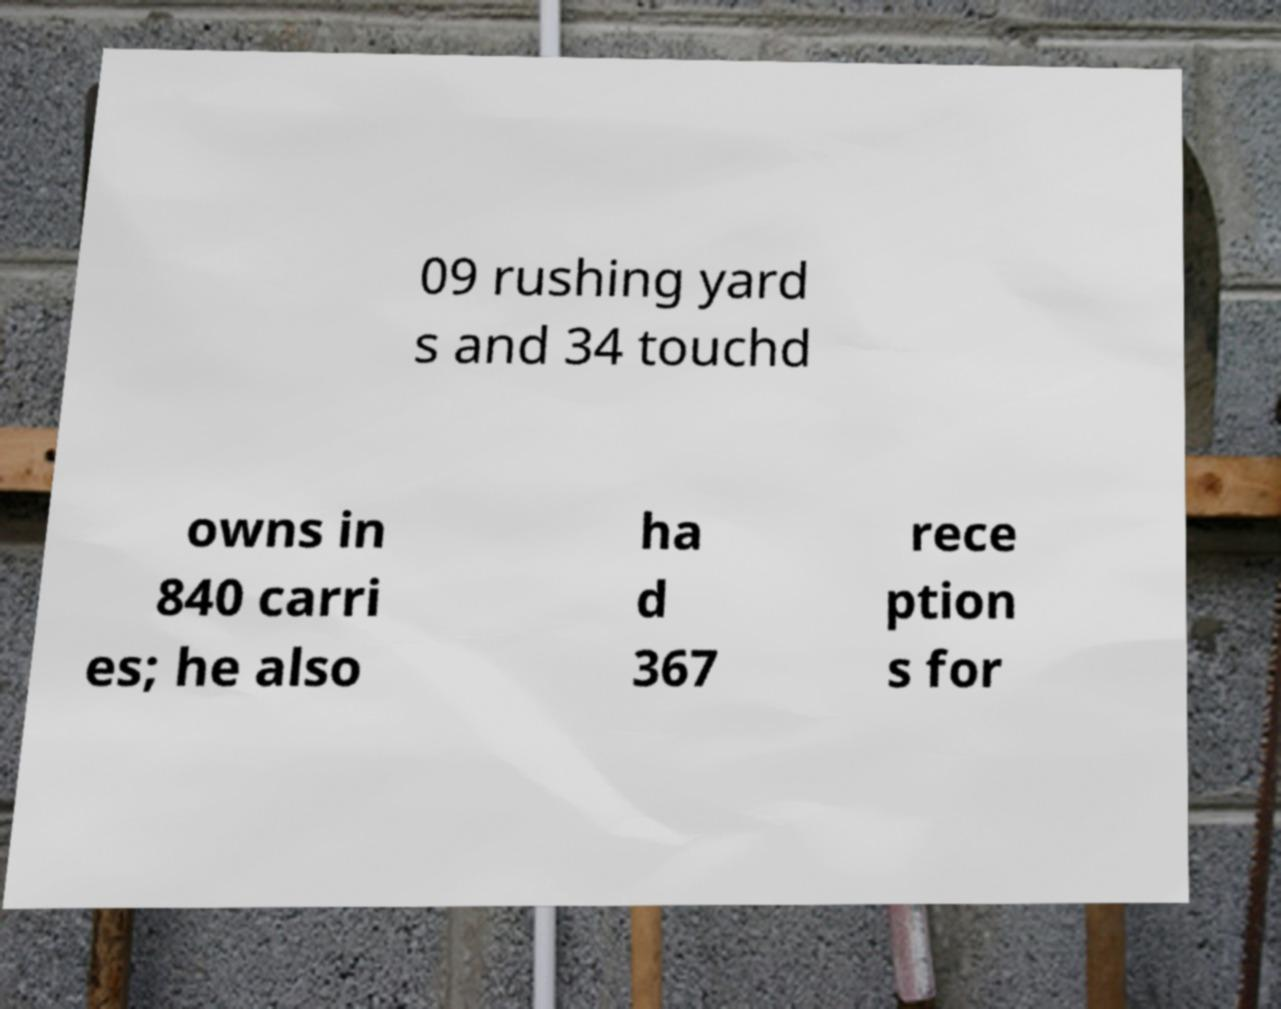Please identify and transcribe the text found in this image. 09 rushing yard s and 34 touchd owns in 840 carri es; he also ha d 367 rece ption s for 